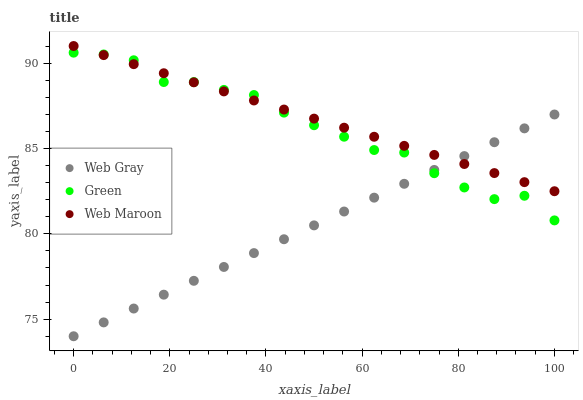Does Web Gray have the minimum area under the curve?
Answer yes or no. Yes. Does Web Maroon have the maximum area under the curve?
Answer yes or no. Yes. Does Green have the minimum area under the curve?
Answer yes or no. No. Does Green have the maximum area under the curve?
Answer yes or no. No. Is Web Gray the smoothest?
Answer yes or no. Yes. Is Green the roughest?
Answer yes or no. Yes. Is Green the smoothest?
Answer yes or no. No. Is Web Gray the roughest?
Answer yes or no. No. Does Web Gray have the lowest value?
Answer yes or no. Yes. Does Green have the lowest value?
Answer yes or no. No. Does Web Maroon have the highest value?
Answer yes or no. Yes. Does Green have the highest value?
Answer yes or no. No. Does Web Gray intersect Green?
Answer yes or no. Yes. Is Web Gray less than Green?
Answer yes or no. No. Is Web Gray greater than Green?
Answer yes or no. No. 